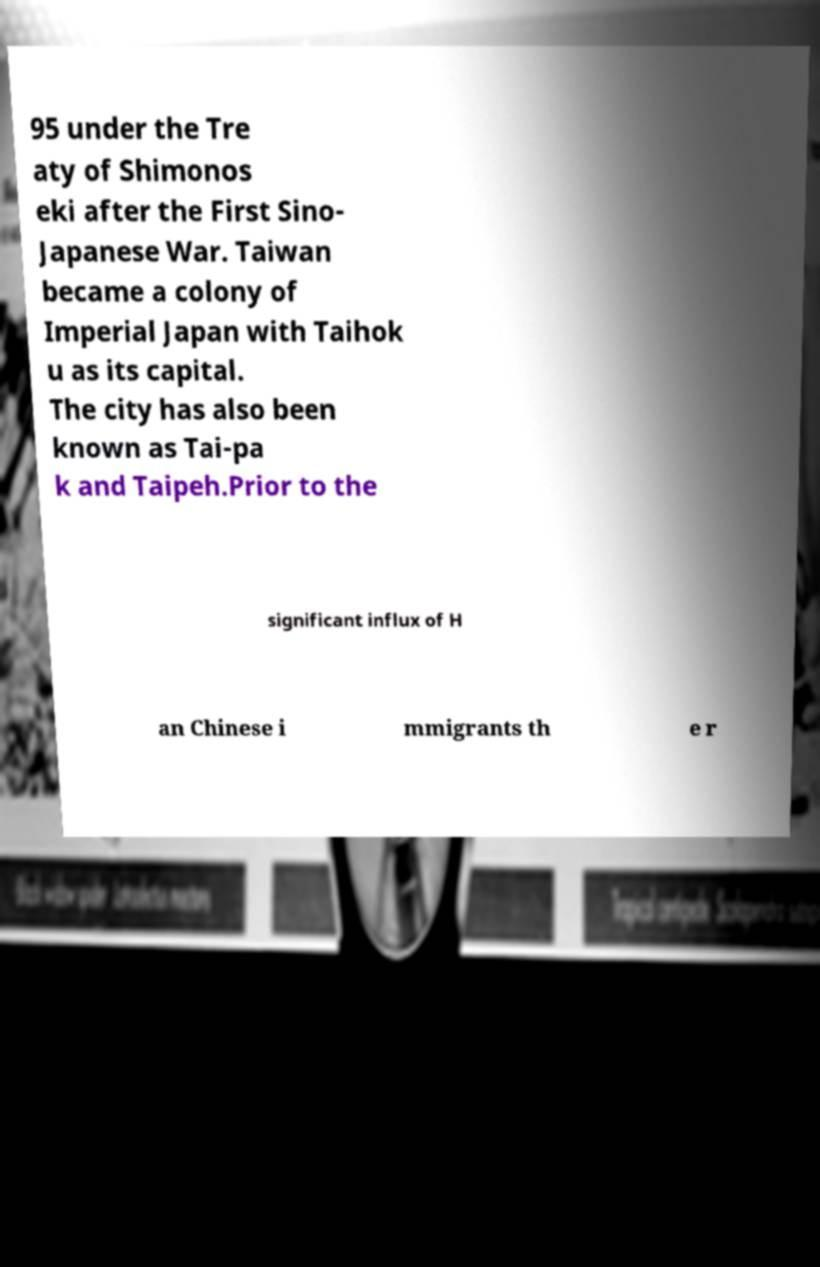Can you read and provide the text displayed in the image?This photo seems to have some interesting text. Can you extract and type it out for me? 95 under the Tre aty of Shimonos eki after the First Sino- Japanese War. Taiwan became a colony of Imperial Japan with Taihok u as its capital. The city has also been known as Tai-pa k and Taipeh.Prior to the significant influx of H an Chinese i mmigrants th e r 